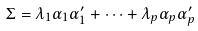Convert formula to latex. <formula><loc_0><loc_0><loc_500><loc_500>\Sigma = \lambda _ { 1 } \alpha _ { 1 } \alpha _ { 1 } ^ { \prime } + \cdots + \lambda _ { p } \alpha _ { p } \alpha _ { p } ^ { \prime }</formula> 